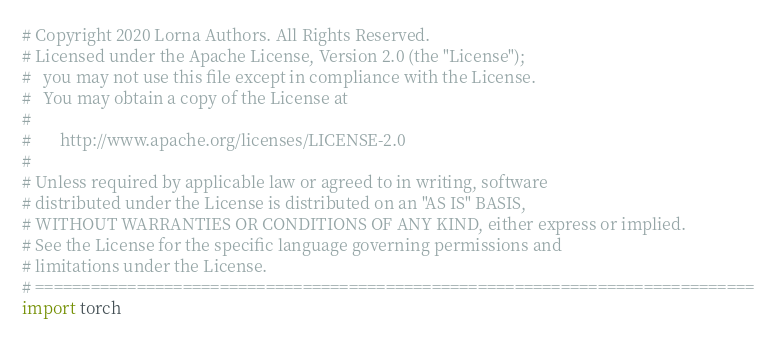Convert code to text. <code><loc_0><loc_0><loc_500><loc_500><_Python_># Copyright 2020 Lorna Authors. All Rights Reserved.
# Licensed under the Apache License, Version 2.0 (the "License");
#   you may not use this file except in compliance with the License.
#   You may obtain a copy of the License at
#
#       http://www.apache.org/licenses/LICENSE-2.0
#
# Unless required by applicable law or agreed to in writing, software
# distributed under the License is distributed on an "AS IS" BASIS,
# WITHOUT WARRANTIES OR CONDITIONS OF ANY KIND, either express or implied.
# See the License for the specific language governing permissions and
# limitations under the License.
# ==============================================================================
import torch</code> 